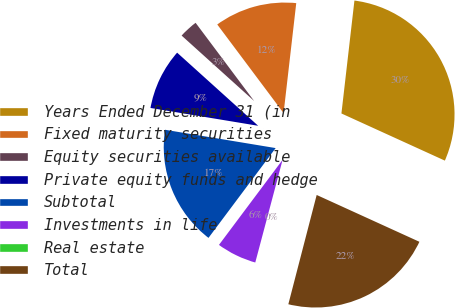Convert chart. <chart><loc_0><loc_0><loc_500><loc_500><pie_chart><fcel>Years Ended December 31 (in<fcel>Fixed maturity securities<fcel>Equity securities available<fcel>Private equity funds and hedge<fcel>Subtotal<fcel>Investments in life<fcel>Real estate<fcel>Total<nl><fcel>29.98%<fcel>12.05%<fcel>3.09%<fcel>9.07%<fcel>17.39%<fcel>6.08%<fcel>0.1%<fcel>22.23%<nl></chart> 